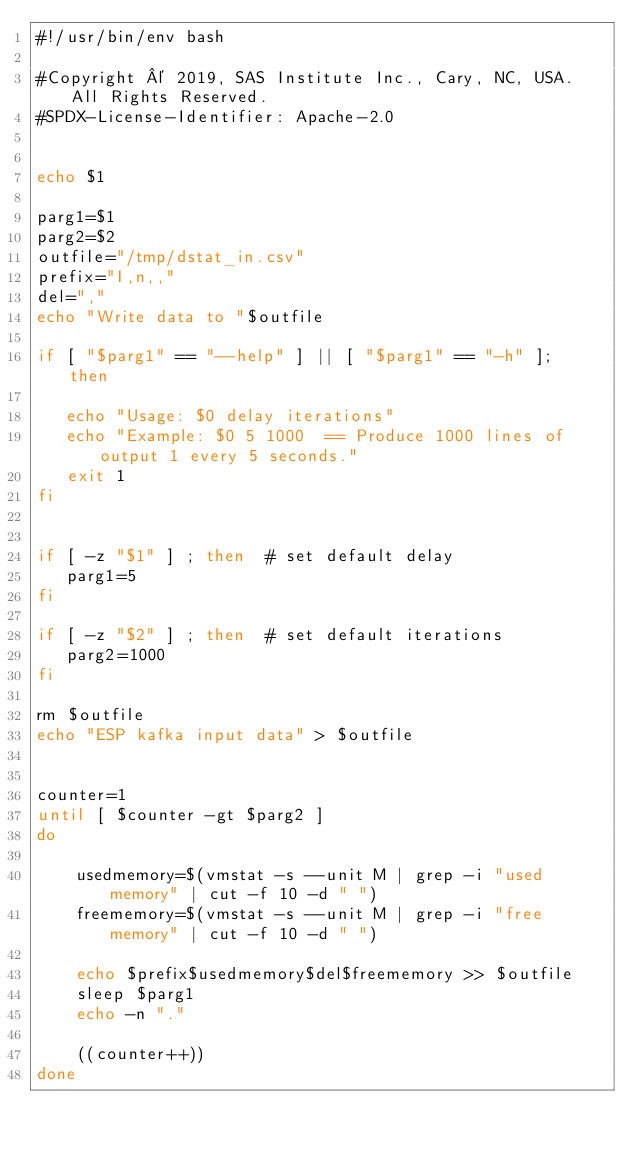Convert code to text. <code><loc_0><loc_0><loc_500><loc_500><_Bash_>#!/usr/bin/env bash 

#Copyright © 2019, SAS Institute Inc., Cary, NC, USA.  All Rights Reserved.
#SPDX-License-Identifier: Apache-2.0


echo $1

parg1=$1
parg2=$2
outfile="/tmp/dstat_in.csv"
prefix="I,n,,"
del=","
echo "Write data to "$outfile

if [ "$parg1" == "--help" ] || [ "$parg1" == "-h" ];  then 

   echo "Usage: $0 delay iterations"
   echo "Example: $0 5 1000  == Produce 1000 lines of output 1 every 5 seconds."
   exit 1 
fi


if [ -z "$1" ] ; then  # set default delay
   parg1=5 
fi

if [ -z "$2" ] ; then  # set default iterations
   parg2=1000 
fi

rm $outfile
echo "ESP kafka input data" > $outfile


counter=1 
until [ $counter -gt $parg2 ]
do 

    usedmemory=$(vmstat -s --unit M | grep -i "used memory" | cut -f 10 -d " ")
    freememory=$(vmstat -s --unit M | grep -i "free memory" | cut -f 10 -d " ")	
    
    echo $prefix$usedmemory$del$freememory >> $outfile
    sleep $parg1
    echo -n "."
	
    ((counter++))
done 


 
</code> 